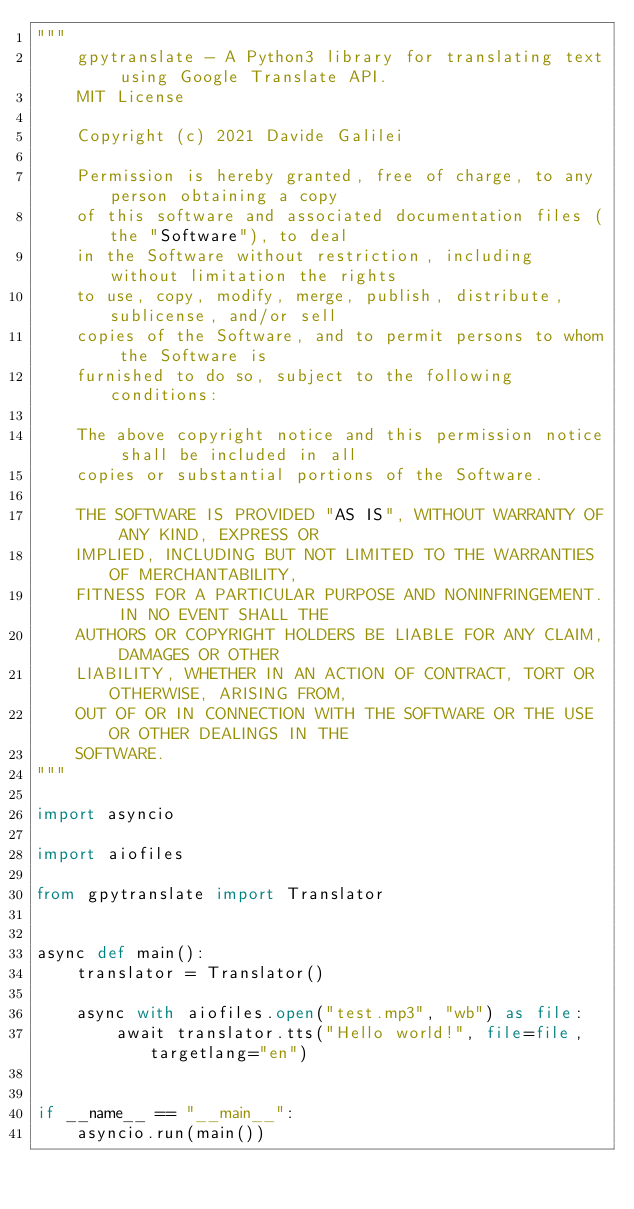<code> <loc_0><loc_0><loc_500><loc_500><_Python_>"""
    gpytranslate - A Python3 library for translating text using Google Translate API.
    MIT License

    Copyright (c) 2021 Davide Galilei

    Permission is hereby granted, free of charge, to any person obtaining a copy
    of this software and associated documentation files (the "Software"), to deal
    in the Software without restriction, including without limitation the rights
    to use, copy, modify, merge, publish, distribute, sublicense, and/or sell
    copies of the Software, and to permit persons to whom the Software is
    furnished to do so, subject to the following conditions:

    The above copyright notice and this permission notice shall be included in all
    copies or substantial portions of the Software.

    THE SOFTWARE IS PROVIDED "AS IS", WITHOUT WARRANTY OF ANY KIND, EXPRESS OR
    IMPLIED, INCLUDING BUT NOT LIMITED TO THE WARRANTIES OF MERCHANTABILITY,
    FITNESS FOR A PARTICULAR PURPOSE AND NONINFRINGEMENT. IN NO EVENT SHALL THE
    AUTHORS OR COPYRIGHT HOLDERS BE LIABLE FOR ANY CLAIM, DAMAGES OR OTHER
    LIABILITY, WHETHER IN AN ACTION OF CONTRACT, TORT OR OTHERWISE, ARISING FROM,
    OUT OF OR IN CONNECTION WITH THE SOFTWARE OR THE USE OR OTHER DEALINGS IN THE
    SOFTWARE.
"""

import asyncio

import aiofiles

from gpytranslate import Translator


async def main():
    translator = Translator()

    async with aiofiles.open("test.mp3", "wb") as file:
        await translator.tts("Hello world!", file=file, targetlang="en")


if __name__ == "__main__":
    asyncio.run(main())
</code> 